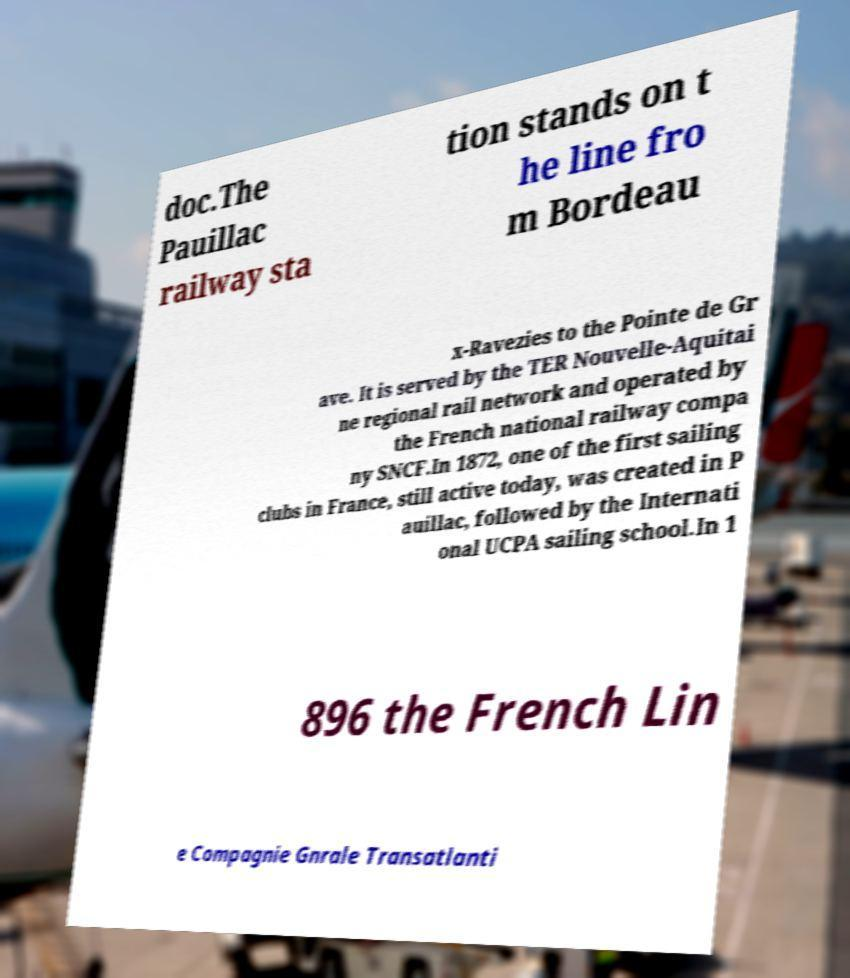Please read and relay the text visible in this image. What does it say? doc.The Pauillac railway sta tion stands on t he line fro m Bordeau x-Ravezies to the Pointe de Gr ave. It is served by the TER Nouvelle-Aquitai ne regional rail network and operated by the French national railway compa ny SNCF.In 1872, one of the first sailing clubs in France, still active today, was created in P auillac, followed by the Internati onal UCPA sailing school.In 1 896 the French Lin e Compagnie Gnrale Transatlanti 